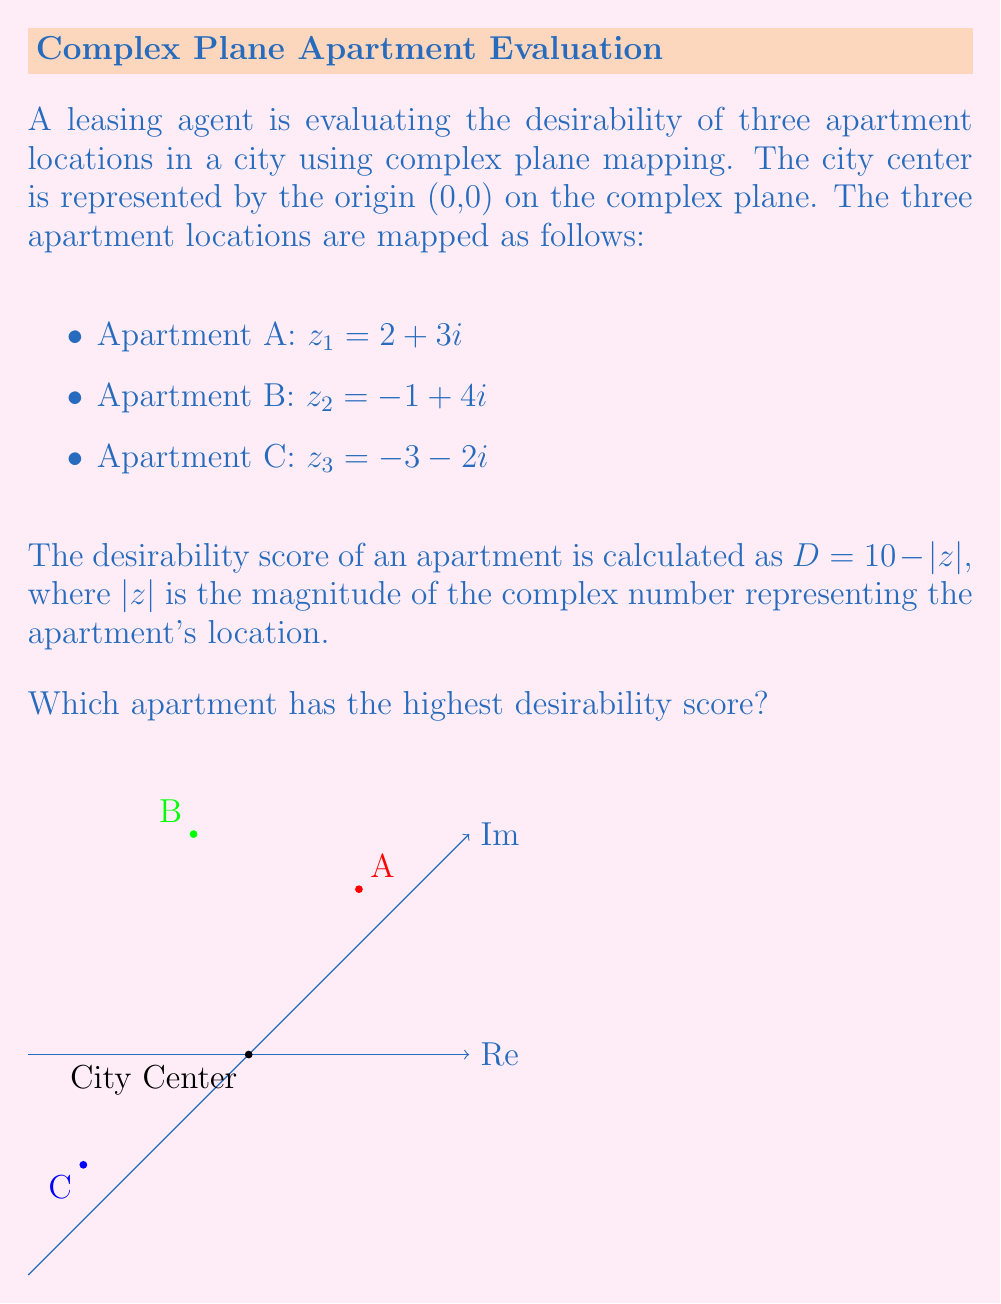Can you solve this math problem? To solve this problem, we need to calculate the magnitude of each complex number and then determine the desirability score for each apartment.

1. For Apartment A: $z_1 = 2 + 3i$
   $|z_1| = \sqrt{2^2 + 3^2} = \sqrt{4 + 9} = \sqrt{13}$
   $D_A = 10 - \sqrt{13} \approx 6.39$

2. For Apartment B: $z_2 = -1 + 4i$
   $|z_2| = \sqrt{(-1)^2 + 4^2} = \sqrt{1 + 16} = \sqrt{17}$
   $D_B = 10 - \sqrt{17} \approx 5.88$

3. For Apartment C: $z_3 = -3 - 2i$
   $|z_3| = \sqrt{(-3)^2 + (-2)^2} = \sqrt{9 + 4} = \sqrt{13}$
   $D_C = 10 - \sqrt{13} \approx 6.39$

Comparing the desirability scores:
$D_A \approx 6.39$
$D_B \approx 5.88$
$D_C \approx 6.39$

We can see that Apartments A and C have the same highest desirability score.
Answer: Apartments A and C (tie) 